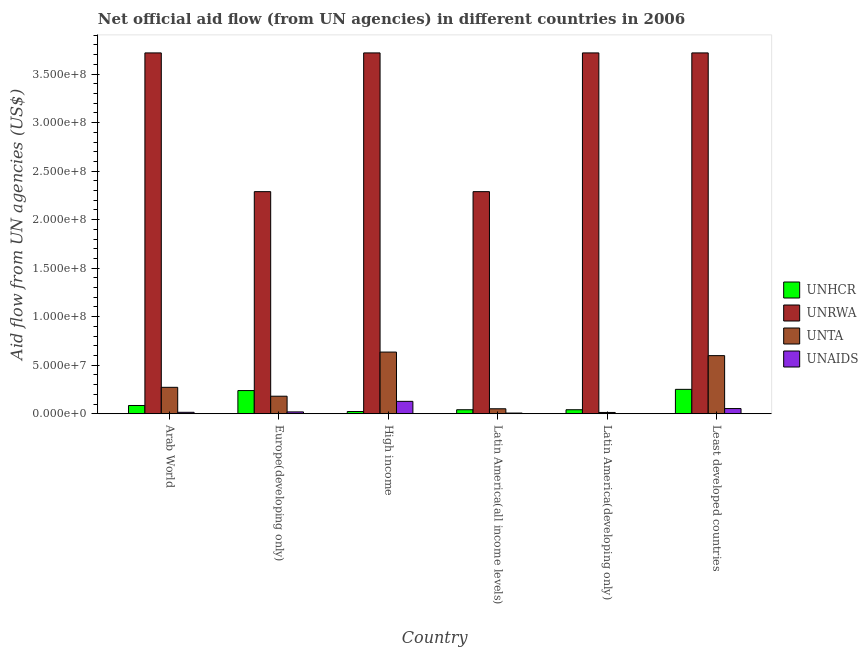How many groups of bars are there?
Offer a terse response. 6. Are the number of bars per tick equal to the number of legend labels?
Ensure brevity in your answer.  Yes. How many bars are there on the 6th tick from the left?
Your response must be concise. 4. How many bars are there on the 1st tick from the right?
Give a very brief answer. 4. What is the label of the 5th group of bars from the left?
Offer a very short reply. Latin America(developing only). In how many cases, is the number of bars for a given country not equal to the number of legend labels?
Offer a very short reply. 0. What is the amount of aid given by unaids in Europe(developing only)?
Your response must be concise. 1.89e+06. Across all countries, what is the maximum amount of aid given by unhcr?
Provide a succinct answer. 2.51e+07. Across all countries, what is the minimum amount of aid given by unta?
Keep it short and to the point. 1.32e+06. In which country was the amount of aid given by unhcr maximum?
Offer a terse response. Least developed countries. In which country was the amount of aid given by unta minimum?
Keep it short and to the point. Latin America(developing only). What is the total amount of aid given by unaids in the graph?
Provide a short and direct response. 2.22e+07. What is the difference between the amount of aid given by unta in High income and that in Least developed countries?
Give a very brief answer. 3.66e+06. What is the difference between the amount of aid given by unta in Latin America(all income levels) and the amount of aid given by unaids in High income?
Your answer should be very brief. -7.65e+06. What is the average amount of aid given by unaids per country?
Your answer should be very brief. 3.70e+06. What is the difference between the amount of aid given by unta and amount of aid given by unhcr in Latin America(developing only)?
Your answer should be compact. -2.79e+06. Is the amount of aid given by unaids in High income less than that in Latin America(all income levels)?
Offer a terse response. No. What is the difference between the highest and the second highest amount of aid given by unaids?
Your answer should be compact. 7.42e+06. What is the difference between the highest and the lowest amount of aid given by unhcr?
Provide a short and direct response. 2.28e+07. In how many countries, is the amount of aid given by unhcr greater than the average amount of aid given by unhcr taken over all countries?
Your answer should be very brief. 2. Is the sum of the amount of aid given by unrwa in High income and Latin America(developing only) greater than the maximum amount of aid given by unaids across all countries?
Provide a succinct answer. Yes. Is it the case that in every country, the sum of the amount of aid given by unta and amount of aid given by unaids is greater than the sum of amount of aid given by unrwa and amount of aid given by unhcr?
Give a very brief answer. No. What does the 1st bar from the left in High income represents?
Make the answer very short. UNHCR. What does the 3rd bar from the right in Europe(developing only) represents?
Make the answer very short. UNRWA. How many bars are there?
Offer a terse response. 24. How many countries are there in the graph?
Give a very brief answer. 6. What is the difference between two consecutive major ticks on the Y-axis?
Make the answer very short. 5.00e+07. Does the graph contain grids?
Your answer should be compact. No. Where does the legend appear in the graph?
Ensure brevity in your answer.  Center right. What is the title of the graph?
Your answer should be very brief. Net official aid flow (from UN agencies) in different countries in 2006. What is the label or title of the Y-axis?
Offer a terse response. Aid flow from UN agencies (US$). What is the Aid flow from UN agencies (US$) in UNHCR in Arab World?
Offer a terse response. 8.50e+06. What is the Aid flow from UN agencies (US$) of UNRWA in Arab World?
Make the answer very short. 3.72e+08. What is the Aid flow from UN agencies (US$) of UNTA in Arab World?
Give a very brief answer. 2.72e+07. What is the Aid flow from UN agencies (US$) in UNAIDS in Arab World?
Provide a succinct answer. 1.48e+06. What is the Aid flow from UN agencies (US$) in UNHCR in Europe(developing only)?
Your answer should be very brief. 2.39e+07. What is the Aid flow from UN agencies (US$) of UNRWA in Europe(developing only)?
Make the answer very short. 2.29e+08. What is the Aid flow from UN agencies (US$) in UNTA in Europe(developing only)?
Make the answer very short. 1.81e+07. What is the Aid flow from UN agencies (US$) of UNAIDS in Europe(developing only)?
Your answer should be compact. 1.89e+06. What is the Aid flow from UN agencies (US$) in UNHCR in High income?
Your answer should be compact. 2.28e+06. What is the Aid flow from UN agencies (US$) of UNRWA in High income?
Provide a short and direct response. 3.72e+08. What is the Aid flow from UN agencies (US$) of UNTA in High income?
Give a very brief answer. 6.35e+07. What is the Aid flow from UN agencies (US$) of UNAIDS in High income?
Make the answer very short. 1.28e+07. What is the Aid flow from UN agencies (US$) of UNHCR in Latin America(all income levels)?
Offer a terse response. 4.11e+06. What is the Aid flow from UN agencies (US$) in UNRWA in Latin America(all income levels)?
Give a very brief answer. 2.29e+08. What is the Aid flow from UN agencies (US$) of UNTA in Latin America(all income levels)?
Ensure brevity in your answer.  5.11e+06. What is the Aid flow from UN agencies (US$) in UNAIDS in Latin America(all income levels)?
Provide a short and direct response. 7.00e+05. What is the Aid flow from UN agencies (US$) of UNHCR in Latin America(developing only)?
Give a very brief answer. 4.11e+06. What is the Aid flow from UN agencies (US$) in UNRWA in Latin America(developing only)?
Ensure brevity in your answer.  3.72e+08. What is the Aid flow from UN agencies (US$) of UNTA in Latin America(developing only)?
Your response must be concise. 1.32e+06. What is the Aid flow from UN agencies (US$) in UNHCR in Least developed countries?
Your response must be concise. 2.51e+07. What is the Aid flow from UN agencies (US$) of UNRWA in Least developed countries?
Your answer should be very brief. 3.72e+08. What is the Aid flow from UN agencies (US$) in UNTA in Least developed countries?
Keep it short and to the point. 5.99e+07. What is the Aid flow from UN agencies (US$) of UNAIDS in Least developed countries?
Your answer should be very brief. 5.34e+06. Across all countries, what is the maximum Aid flow from UN agencies (US$) in UNHCR?
Provide a short and direct response. 2.51e+07. Across all countries, what is the maximum Aid flow from UN agencies (US$) of UNRWA?
Make the answer very short. 3.72e+08. Across all countries, what is the maximum Aid flow from UN agencies (US$) of UNTA?
Your answer should be very brief. 6.35e+07. Across all countries, what is the maximum Aid flow from UN agencies (US$) of UNAIDS?
Provide a succinct answer. 1.28e+07. Across all countries, what is the minimum Aid flow from UN agencies (US$) in UNHCR?
Provide a succinct answer. 2.28e+06. Across all countries, what is the minimum Aid flow from UN agencies (US$) in UNRWA?
Your response must be concise. 2.29e+08. Across all countries, what is the minimum Aid flow from UN agencies (US$) in UNTA?
Your answer should be very brief. 1.32e+06. Across all countries, what is the minimum Aid flow from UN agencies (US$) of UNAIDS?
Your answer should be compact. 3.00e+04. What is the total Aid flow from UN agencies (US$) of UNHCR in the graph?
Your response must be concise. 6.80e+07. What is the total Aid flow from UN agencies (US$) in UNRWA in the graph?
Your answer should be very brief. 1.94e+09. What is the total Aid flow from UN agencies (US$) in UNTA in the graph?
Your response must be concise. 1.75e+08. What is the total Aid flow from UN agencies (US$) in UNAIDS in the graph?
Your response must be concise. 2.22e+07. What is the difference between the Aid flow from UN agencies (US$) of UNHCR in Arab World and that in Europe(developing only)?
Your answer should be compact. -1.54e+07. What is the difference between the Aid flow from UN agencies (US$) in UNRWA in Arab World and that in Europe(developing only)?
Ensure brevity in your answer.  1.43e+08. What is the difference between the Aid flow from UN agencies (US$) in UNTA in Arab World and that in Europe(developing only)?
Your answer should be very brief. 9.16e+06. What is the difference between the Aid flow from UN agencies (US$) of UNAIDS in Arab World and that in Europe(developing only)?
Your answer should be compact. -4.10e+05. What is the difference between the Aid flow from UN agencies (US$) of UNHCR in Arab World and that in High income?
Offer a very short reply. 6.22e+06. What is the difference between the Aid flow from UN agencies (US$) in UNRWA in Arab World and that in High income?
Provide a short and direct response. 0. What is the difference between the Aid flow from UN agencies (US$) in UNTA in Arab World and that in High income?
Keep it short and to the point. -3.63e+07. What is the difference between the Aid flow from UN agencies (US$) in UNAIDS in Arab World and that in High income?
Your answer should be compact. -1.13e+07. What is the difference between the Aid flow from UN agencies (US$) in UNHCR in Arab World and that in Latin America(all income levels)?
Ensure brevity in your answer.  4.39e+06. What is the difference between the Aid flow from UN agencies (US$) of UNRWA in Arab World and that in Latin America(all income levels)?
Your response must be concise. 1.43e+08. What is the difference between the Aid flow from UN agencies (US$) in UNTA in Arab World and that in Latin America(all income levels)?
Keep it short and to the point. 2.21e+07. What is the difference between the Aid flow from UN agencies (US$) of UNAIDS in Arab World and that in Latin America(all income levels)?
Keep it short and to the point. 7.80e+05. What is the difference between the Aid flow from UN agencies (US$) in UNHCR in Arab World and that in Latin America(developing only)?
Your response must be concise. 4.39e+06. What is the difference between the Aid flow from UN agencies (US$) of UNTA in Arab World and that in Latin America(developing only)?
Make the answer very short. 2.59e+07. What is the difference between the Aid flow from UN agencies (US$) in UNAIDS in Arab World and that in Latin America(developing only)?
Ensure brevity in your answer.  1.45e+06. What is the difference between the Aid flow from UN agencies (US$) in UNHCR in Arab World and that in Least developed countries?
Provide a succinct answer. -1.66e+07. What is the difference between the Aid flow from UN agencies (US$) of UNRWA in Arab World and that in Least developed countries?
Give a very brief answer. 0. What is the difference between the Aid flow from UN agencies (US$) of UNTA in Arab World and that in Least developed countries?
Your response must be concise. -3.27e+07. What is the difference between the Aid flow from UN agencies (US$) of UNAIDS in Arab World and that in Least developed countries?
Make the answer very short. -3.86e+06. What is the difference between the Aid flow from UN agencies (US$) in UNHCR in Europe(developing only) and that in High income?
Give a very brief answer. 2.16e+07. What is the difference between the Aid flow from UN agencies (US$) in UNRWA in Europe(developing only) and that in High income?
Give a very brief answer. -1.43e+08. What is the difference between the Aid flow from UN agencies (US$) in UNTA in Europe(developing only) and that in High income?
Ensure brevity in your answer.  -4.55e+07. What is the difference between the Aid flow from UN agencies (US$) of UNAIDS in Europe(developing only) and that in High income?
Provide a succinct answer. -1.09e+07. What is the difference between the Aid flow from UN agencies (US$) in UNHCR in Europe(developing only) and that in Latin America(all income levels)?
Ensure brevity in your answer.  1.98e+07. What is the difference between the Aid flow from UN agencies (US$) in UNTA in Europe(developing only) and that in Latin America(all income levels)?
Your response must be concise. 1.30e+07. What is the difference between the Aid flow from UN agencies (US$) of UNAIDS in Europe(developing only) and that in Latin America(all income levels)?
Ensure brevity in your answer.  1.19e+06. What is the difference between the Aid flow from UN agencies (US$) of UNHCR in Europe(developing only) and that in Latin America(developing only)?
Give a very brief answer. 1.98e+07. What is the difference between the Aid flow from UN agencies (US$) of UNRWA in Europe(developing only) and that in Latin America(developing only)?
Keep it short and to the point. -1.43e+08. What is the difference between the Aid flow from UN agencies (US$) of UNTA in Europe(developing only) and that in Latin America(developing only)?
Offer a very short reply. 1.67e+07. What is the difference between the Aid flow from UN agencies (US$) of UNAIDS in Europe(developing only) and that in Latin America(developing only)?
Provide a short and direct response. 1.86e+06. What is the difference between the Aid flow from UN agencies (US$) of UNHCR in Europe(developing only) and that in Least developed countries?
Make the answer very short. -1.25e+06. What is the difference between the Aid flow from UN agencies (US$) in UNRWA in Europe(developing only) and that in Least developed countries?
Your answer should be compact. -1.43e+08. What is the difference between the Aid flow from UN agencies (US$) of UNTA in Europe(developing only) and that in Least developed countries?
Your answer should be very brief. -4.18e+07. What is the difference between the Aid flow from UN agencies (US$) of UNAIDS in Europe(developing only) and that in Least developed countries?
Your response must be concise. -3.45e+06. What is the difference between the Aid flow from UN agencies (US$) of UNHCR in High income and that in Latin America(all income levels)?
Offer a very short reply. -1.83e+06. What is the difference between the Aid flow from UN agencies (US$) in UNRWA in High income and that in Latin America(all income levels)?
Offer a very short reply. 1.43e+08. What is the difference between the Aid flow from UN agencies (US$) in UNTA in High income and that in Latin America(all income levels)?
Your response must be concise. 5.84e+07. What is the difference between the Aid flow from UN agencies (US$) in UNAIDS in High income and that in Latin America(all income levels)?
Keep it short and to the point. 1.21e+07. What is the difference between the Aid flow from UN agencies (US$) of UNHCR in High income and that in Latin America(developing only)?
Keep it short and to the point. -1.83e+06. What is the difference between the Aid flow from UN agencies (US$) in UNRWA in High income and that in Latin America(developing only)?
Your answer should be compact. 0. What is the difference between the Aid flow from UN agencies (US$) in UNTA in High income and that in Latin America(developing only)?
Your answer should be very brief. 6.22e+07. What is the difference between the Aid flow from UN agencies (US$) of UNAIDS in High income and that in Latin America(developing only)?
Your answer should be very brief. 1.27e+07. What is the difference between the Aid flow from UN agencies (US$) of UNHCR in High income and that in Least developed countries?
Give a very brief answer. -2.28e+07. What is the difference between the Aid flow from UN agencies (US$) of UNRWA in High income and that in Least developed countries?
Keep it short and to the point. 0. What is the difference between the Aid flow from UN agencies (US$) of UNTA in High income and that in Least developed countries?
Offer a terse response. 3.66e+06. What is the difference between the Aid flow from UN agencies (US$) of UNAIDS in High income and that in Least developed countries?
Your response must be concise. 7.42e+06. What is the difference between the Aid flow from UN agencies (US$) in UNRWA in Latin America(all income levels) and that in Latin America(developing only)?
Provide a succinct answer. -1.43e+08. What is the difference between the Aid flow from UN agencies (US$) in UNTA in Latin America(all income levels) and that in Latin America(developing only)?
Your response must be concise. 3.79e+06. What is the difference between the Aid flow from UN agencies (US$) in UNAIDS in Latin America(all income levels) and that in Latin America(developing only)?
Offer a terse response. 6.70e+05. What is the difference between the Aid flow from UN agencies (US$) in UNHCR in Latin America(all income levels) and that in Least developed countries?
Your answer should be compact. -2.10e+07. What is the difference between the Aid flow from UN agencies (US$) in UNRWA in Latin America(all income levels) and that in Least developed countries?
Provide a succinct answer. -1.43e+08. What is the difference between the Aid flow from UN agencies (US$) in UNTA in Latin America(all income levels) and that in Least developed countries?
Provide a succinct answer. -5.48e+07. What is the difference between the Aid flow from UN agencies (US$) in UNAIDS in Latin America(all income levels) and that in Least developed countries?
Give a very brief answer. -4.64e+06. What is the difference between the Aid flow from UN agencies (US$) in UNHCR in Latin America(developing only) and that in Least developed countries?
Your answer should be very brief. -2.10e+07. What is the difference between the Aid flow from UN agencies (US$) in UNTA in Latin America(developing only) and that in Least developed countries?
Your answer should be compact. -5.86e+07. What is the difference between the Aid flow from UN agencies (US$) of UNAIDS in Latin America(developing only) and that in Least developed countries?
Make the answer very short. -5.31e+06. What is the difference between the Aid flow from UN agencies (US$) in UNHCR in Arab World and the Aid flow from UN agencies (US$) in UNRWA in Europe(developing only)?
Ensure brevity in your answer.  -2.20e+08. What is the difference between the Aid flow from UN agencies (US$) in UNHCR in Arab World and the Aid flow from UN agencies (US$) in UNTA in Europe(developing only)?
Offer a terse response. -9.56e+06. What is the difference between the Aid flow from UN agencies (US$) in UNHCR in Arab World and the Aid flow from UN agencies (US$) in UNAIDS in Europe(developing only)?
Your answer should be very brief. 6.61e+06. What is the difference between the Aid flow from UN agencies (US$) of UNRWA in Arab World and the Aid flow from UN agencies (US$) of UNTA in Europe(developing only)?
Offer a very short reply. 3.54e+08. What is the difference between the Aid flow from UN agencies (US$) of UNRWA in Arab World and the Aid flow from UN agencies (US$) of UNAIDS in Europe(developing only)?
Offer a terse response. 3.70e+08. What is the difference between the Aid flow from UN agencies (US$) in UNTA in Arab World and the Aid flow from UN agencies (US$) in UNAIDS in Europe(developing only)?
Make the answer very short. 2.53e+07. What is the difference between the Aid flow from UN agencies (US$) in UNHCR in Arab World and the Aid flow from UN agencies (US$) in UNRWA in High income?
Offer a terse response. -3.63e+08. What is the difference between the Aid flow from UN agencies (US$) of UNHCR in Arab World and the Aid flow from UN agencies (US$) of UNTA in High income?
Provide a succinct answer. -5.50e+07. What is the difference between the Aid flow from UN agencies (US$) of UNHCR in Arab World and the Aid flow from UN agencies (US$) of UNAIDS in High income?
Provide a short and direct response. -4.26e+06. What is the difference between the Aid flow from UN agencies (US$) in UNRWA in Arab World and the Aid flow from UN agencies (US$) in UNTA in High income?
Make the answer very short. 3.08e+08. What is the difference between the Aid flow from UN agencies (US$) of UNRWA in Arab World and the Aid flow from UN agencies (US$) of UNAIDS in High income?
Make the answer very short. 3.59e+08. What is the difference between the Aid flow from UN agencies (US$) of UNTA in Arab World and the Aid flow from UN agencies (US$) of UNAIDS in High income?
Offer a terse response. 1.45e+07. What is the difference between the Aid flow from UN agencies (US$) in UNHCR in Arab World and the Aid flow from UN agencies (US$) in UNRWA in Latin America(all income levels)?
Offer a very short reply. -2.20e+08. What is the difference between the Aid flow from UN agencies (US$) of UNHCR in Arab World and the Aid flow from UN agencies (US$) of UNTA in Latin America(all income levels)?
Offer a very short reply. 3.39e+06. What is the difference between the Aid flow from UN agencies (US$) in UNHCR in Arab World and the Aid flow from UN agencies (US$) in UNAIDS in Latin America(all income levels)?
Your answer should be very brief. 7.80e+06. What is the difference between the Aid flow from UN agencies (US$) of UNRWA in Arab World and the Aid flow from UN agencies (US$) of UNTA in Latin America(all income levels)?
Keep it short and to the point. 3.67e+08. What is the difference between the Aid flow from UN agencies (US$) of UNRWA in Arab World and the Aid flow from UN agencies (US$) of UNAIDS in Latin America(all income levels)?
Offer a very short reply. 3.71e+08. What is the difference between the Aid flow from UN agencies (US$) of UNTA in Arab World and the Aid flow from UN agencies (US$) of UNAIDS in Latin America(all income levels)?
Keep it short and to the point. 2.65e+07. What is the difference between the Aid flow from UN agencies (US$) in UNHCR in Arab World and the Aid flow from UN agencies (US$) in UNRWA in Latin America(developing only)?
Give a very brief answer. -3.63e+08. What is the difference between the Aid flow from UN agencies (US$) in UNHCR in Arab World and the Aid flow from UN agencies (US$) in UNTA in Latin America(developing only)?
Your answer should be very brief. 7.18e+06. What is the difference between the Aid flow from UN agencies (US$) of UNHCR in Arab World and the Aid flow from UN agencies (US$) of UNAIDS in Latin America(developing only)?
Keep it short and to the point. 8.47e+06. What is the difference between the Aid flow from UN agencies (US$) in UNRWA in Arab World and the Aid flow from UN agencies (US$) in UNTA in Latin America(developing only)?
Keep it short and to the point. 3.70e+08. What is the difference between the Aid flow from UN agencies (US$) in UNRWA in Arab World and the Aid flow from UN agencies (US$) in UNAIDS in Latin America(developing only)?
Offer a very short reply. 3.72e+08. What is the difference between the Aid flow from UN agencies (US$) of UNTA in Arab World and the Aid flow from UN agencies (US$) of UNAIDS in Latin America(developing only)?
Your answer should be compact. 2.72e+07. What is the difference between the Aid flow from UN agencies (US$) in UNHCR in Arab World and the Aid flow from UN agencies (US$) in UNRWA in Least developed countries?
Offer a terse response. -3.63e+08. What is the difference between the Aid flow from UN agencies (US$) in UNHCR in Arab World and the Aid flow from UN agencies (US$) in UNTA in Least developed countries?
Offer a very short reply. -5.14e+07. What is the difference between the Aid flow from UN agencies (US$) in UNHCR in Arab World and the Aid flow from UN agencies (US$) in UNAIDS in Least developed countries?
Provide a succinct answer. 3.16e+06. What is the difference between the Aid flow from UN agencies (US$) of UNRWA in Arab World and the Aid flow from UN agencies (US$) of UNTA in Least developed countries?
Make the answer very short. 3.12e+08. What is the difference between the Aid flow from UN agencies (US$) in UNRWA in Arab World and the Aid flow from UN agencies (US$) in UNAIDS in Least developed countries?
Provide a short and direct response. 3.66e+08. What is the difference between the Aid flow from UN agencies (US$) in UNTA in Arab World and the Aid flow from UN agencies (US$) in UNAIDS in Least developed countries?
Offer a terse response. 2.19e+07. What is the difference between the Aid flow from UN agencies (US$) of UNHCR in Europe(developing only) and the Aid flow from UN agencies (US$) of UNRWA in High income?
Provide a short and direct response. -3.48e+08. What is the difference between the Aid flow from UN agencies (US$) in UNHCR in Europe(developing only) and the Aid flow from UN agencies (US$) in UNTA in High income?
Provide a succinct answer. -3.97e+07. What is the difference between the Aid flow from UN agencies (US$) in UNHCR in Europe(developing only) and the Aid flow from UN agencies (US$) in UNAIDS in High income?
Provide a short and direct response. 1.11e+07. What is the difference between the Aid flow from UN agencies (US$) of UNRWA in Europe(developing only) and the Aid flow from UN agencies (US$) of UNTA in High income?
Ensure brevity in your answer.  1.65e+08. What is the difference between the Aid flow from UN agencies (US$) in UNRWA in Europe(developing only) and the Aid flow from UN agencies (US$) in UNAIDS in High income?
Your answer should be very brief. 2.16e+08. What is the difference between the Aid flow from UN agencies (US$) in UNTA in Europe(developing only) and the Aid flow from UN agencies (US$) in UNAIDS in High income?
Make the answer very short. 5.30e+06. What is the difference between the Aid flow from UN agencies (US$) of UNHCR in Europe(developing only) and the Aid flow from UN agencies (US$) of UNRWA in Latin America(all income levels)?
Provide a short and direct response. -2.05e+08. What is the difference between the Aid flow from UN agencies (US$) of UNHCR in Europe(developing only) and the Aid flow from UN agencies (US$) of UNTA in Latin America(all income levels)?
Ensure brevity in your answer.  1.88e+07. What is the difference between the Aid flow from UN agencies (US$) in UNHCR in Europe(developing only) and the Aid flow from UN agencies (US$) in UNAIDS in Latin America(all income levels)?
Make the answer very short. 2.32e+07. What is the difference between the Aid flow from UN agencies (US$) in UNRWA in Europe(developing only) and the Aid flow from UN agencies (US$) in UNTA in Latin America(all income levels)?
Offer a terse response. 2.24e+08. What is the difference between the Aid flow from UN agencies (US$) in UNRWA in Europe(developing only) and the Aid flow from UN agencies (US$) in UNAIDS in Latin America(all income levels)?
Ensure brevity in your answer.  2.28e+08. What is the difference between the Aid flow from UN agencies (US$) of UNTA in Europe(developing only) and the Aid flow from UN agencies (US$) of UNAIDS in Latin America(all income levels)?
Your response must be concise. 1.74e+07. What is the difference between the Aid flow from UN agencies (US$) of UNHCR in Europe(developing only) and the Aid flow from UN agencies (US$) of UNRWA in Latin America(developing only)?
Provide a short and direct response. -3.48e+08. What is the difference between the Aid flow from UN agencies (US$) in UNHCR in Europe(developing only) and the Aid flow from UN agencies (US$) in UNTA in Latin America(developing only)?
Provide a short and direct response. 2.26e+07. What is the difference between the Aid flow from UN agencies (US$) in UNHCR in Europe(developing only) and the Aid flow from UN agencies (US$) in UNAIDS in Latin America(developing only)?
Your answer should be very brief. 2.38e+07. What is the difference between the Aid flow from UN agencies (US$) of UNRWA in Europe(developing only) and the Aid flow from UN agencies (US$) of UNTA in Latin America(developing only)?
Your response must be concise. 2.28e+08. What is the difference between the Aid flow from UN agencies (US$) of UNRWA in Europe(developing only) and the Aid flow from UN agencies (US$) of UNAIDS in Latin America(developing only)?
Your answer should be compact. 2.29e+08. What is the difference between the Aid flow from UN agencies (US$) of UNTA in Europe(developing only) and the Aid flow from UN agencies (US$) of UNAIDS in Latin America(developing only)?
Make the answer very short. 1.80e+07. What is the difference between the Aid flow from UN agencies (US$) of UNHCR in Europe(developing only) and the Aid flow from UN agencies (US$) of UNRWA in Least developed countries?
Provide a succinct answer. -3.48e+08. What is the difference between the Aid flow from UN agencies (US$) of UNHCR in Europe(developing only) and the Aid flow from UN agencies (US$) of UNTA in Least developed countries?
Make the answer very short. -3.60e+07. What is the difference between the Aid flow from UN agencies (US$) in UNHCR in Europe(developing only) and the Aid flow from UN agencies (US$) in UNAIDS in Least developed countries?
Provide a succinct answer. 1.85e+07. What is the difference between the Aid flow from UN agencies (US$) in UNRWA in Europe(developing only) and the Aid flow from UN agencies (US$) in UNTA in Least developed countries?
Provide a short and direct response. 1.69e+08. What is the difference between the Aid flow from UN agencies (US$) in UNRWA in Europe(developing only) and the Aid flow from UN agencies (US$) in UNAIDS in Least developed countries?
Offer a very short reply. 2.24e+08. What is the difference between the Aid flow from UN agencies (US$) in UNTA in Europe(developing only) and the Aid flow from UN agencies (US$) in UNAIDS in Least developed countries?
Offer a very short reply. 1.27e+07. What is the difference between the Aid flow from UN agencies (US$) of UNHCR in High income and the Aid flow from UN agencies (US$) of UNRWA in Latin America(all income levels)?
Your answer should be compact. -2.27e+08. What is the difference between the Aid flow from UN agencies (US$) in UNHCR in High income and the Aid flow from UN agencies (US$) in UNTA in Latin America(all income levels)?
Your response must be concise. -2.83e+06. What is the difference between the Aid flow from UN agencies (US$) in UNHCR in High income and the Aid flow from UN agencies (US$) in UNAIDS in Latin America(all income levels)?
Give a very brief answer. 1.58e+06. What is the difference between the Aid flow from UN agencies (US$) of UNRWA in High income and the Aid flow from UN agencies (US$) of UNTA in Latin America(all income levels)?
Your answer should be very brief. 3.67e+08. What is the difference between the Aid flow from UN agencies (US$) in UNRWA in High income and the Aid flow from UN agencies (US$) in UNAIDS in Latin America(all income levels)?
Give a very brief answer. 3.71e+08. What is the difference between the Aid flow from UN agencies (US$) in UNTA in High income and the Aid flow from UN agencies (US$) in UNAIDS in Latin America(all income levels)?
Offer a terse response. 6.28e+07. What is the difference between the Aid flow from UN agencies (US$) in UNHCR in High income and the Aid flow from UN agencies (US$) in UNRWA in Latin America(developing only)?
Keep it short and to the point. -3.70e+08. What is the difference between the Aid flow from UN agencies (US$) in UNHCR in High income and the Aid flow from UN agencies (US$) in UNTA in Latin America(developing only)?
Keep it short and to the point. 9.60e+05. What is the difference between the Aid flow from UN agencies (US$) in UNHCR in High income and the Aid flow from UN agencies (US$) in UNAIDS in Latin America(developing only)?
Provide a short and direct response. 2.25e+06. What is the difference between the Aid flow from UN agencies (US$) in UNRWA in High income and the Aid flow from UN agencies (US$) in UNTA in Latin America(developing only)?
Your answer should be very brief. 3.70e+08. What is the difference between the Aid flow from UN agencies (US$) in UNRWA in High income and the Aid flow from UN agencies (US$) in UNAIDS in Latin America(developing only)?
Your response must be concise. 3.72e+08. What is the difference between the Aid flow from UN agencies (US$) in UNTA in High income and the Aid flow from UN agencies (US$) in UNAIDS in Latin America(developing only)?
Provide a short and direct response. 6.35e+07. What is the difference between the Aid flow from UN agencies (US$) of UNHCR in High income and the Aid flow from UN agencies (US$) of UNRWA in Least developed countries?
Offer a very short reply. -3.70e+08. What is the difference between the Aid flow from UN agencies (US$) of UNHCR in High income and the Aid flow from UN agencies (US$) of UNTA in Least developed countries?
Keep it short and to the point. -5.76e+07. What is the difference between the Aid flow from UN agencies (US$) in UNHCR in High income and the Aid flow from UN agencies (US$) in UNAIDS in Least developed countries?
Your answer should be very brief. -3.06e+06. What is the difference between the Aid flow from UN agencies (US$) in UNRWA in High income and the Aid flow from UN agencies (US$) in UNTA in Least developed countries?
Provide a short and direct response. 3.12e+08. What is the difference between the Aid flow from UN agencies (US$) of UNRWA in High income and the Aid flow from UN agencies (US$) of UNAIDS in Least developed countries?
Keep it short and to the point. 3.66e+08. What is the difference between the Aid flow from UN agencies (US$) in UNTA in High income and the Aid flow from UN agencies (US$) in UNAIDS in Least developed countries?
Keep it short and to the point. 5.82e+07. What is the difference between the Aid flow from UN agencies (US$) of UNHCR in Latin America(all income levels) and the Aid flow from UN agencies (US$) of UNRWA in Latin America(developing only)?
Keep it short and to the point. -3.68e+08. What is the difference between the Aid flow from UN agencies (US$) in UNHCR in Latin America(all income levels) and the Aid flow from UN agencies (US$) in UNTA in Latin America(developing only)?
Provide a succinct answer. 2.79e+06. What is the difference between the Aid flow from UN agencies (US$) of UNHCR in Latin America(all income levels) and the Aid flow from UN agencies (US$) of UNAIDS in Latin America(developing only)?
Your response must be concise. 4.08e+06. What is the difference between the Aid flow from UN agencies (US$) in UNRWA in Latin America(all income levels) and the Aid flow from UN agencies (US$) in UNTA in Latin America(developing only)?
Ensure brevity in your answer.  2.28e+08. What is the difference between the Aid flow from UN agencies (US$) in UNRWA in Latin America(all income levels) and the Aid flow from UN agencies (US$) in UNAIDS in Latin America(developing only)?
Ensure brevity in your answer.  2.29e+08. What is the difference between the Aid flow from UN agencies (US$) in UNTA in Latin America(all income levels) and the Aid flow from UN agencies (US$) in UNAIDS in Latin America(developing only)?
Give a very brief answer. 5.08e+06. What is the difference between the Aid flow from UN agencies (US$) of UNHCR in Latin America(all income levels) and the Aid flow from UN agencies (US$) of UNRWA in Least developed countries?
Your response must be concise. -3.68e+08. What is the difference between the Aid flow from UN agencies (US$) in UNHCR in Latin America(all income levels) and the Aid flow from UN agencies (US$) in UNTA in Least developed countries?
Make the answer very short. -5.58e+07. What is the difference between the Aid flow from UN agencies (US$) in UNHCR in Latin America(all income levels) and the Aid flow from UN agencies (US$) in UNAIDS in Least developed countries?
Offer a very short reply. -1.23e+06. What is the difference between the Aid flow from UN agencies (US$) in UNRWA in Latin America(all income levels) and the Aid flow from UN agencies (US$) in UNTA in Least developed countries?
Your response must be concise. 1.69e+08. What is the difference between the Aid flow from UN agencies (US$) in UNRWA in Latin America(all income levels) and the Aid flow from UN agencies (US$) in UNAIDS in Least developed countries?
Keep it short and to the point. 2.24e+08. What is the difference between the Aid flow from UN agencies (US$) of UNHCR in Latin America(developing only) and the Aid flow from UN agencies (US$) of UNRWA in Least developed countries?
Your answer should be very brief. -3.68e+08. What is the difference between the Aid flow from UN agencies (US$) in UNHCR in Latin America(developing only) and the Aid flow from UN agencies (US$) in UNTA in Least developed countries?
Offer a terse response. -5.58e+07. What is the difference between the Aid flow from UN agencies (US$) of UNHCR in Latin America(developing only) and the Aid flow from UN agencies (US$) of UNAIDS in Least developed countries?
Keep it short and to the point. -1.23e+06. What is the difference between the Aid flow from UN agencies (US$) of UNRWA in Latin America(developing only) and the Aid flow from UN agencies (US$) of UNTA in Least developed countries?
Offer a terse response. 3.12e+08. What is the difference between the Aid flow from UN agencies (US$) in UNRWA in Latin America(developing only) and the Aid flow from UN agencies (US$) in UNAIDS in Least developed countries?
Make the answer very short. 3.66e+08. What is the difference between the Aid flow from UN agencies (US$) in UNTA in Latin America(developing only) and the Aid flow from UN agencies (US$) in UNAIDS in Least developed countries?
Offer a very short reply. -4.02e+06. What is the average Aid flow from UN agencies (US$) of UNHCR per country?
Provide a succinct answer. 1.13e+07. What is the average Aid flow from UN agencies (US$) in UNRWA per country?
Your answer should be compact. 3.24e+08. What is the average Aid flow from UN agencies (US$) of UNTA per country?
Offer a terse response. 2.92e+07. What is the average Aid flow from UN agencies (US$) in UNAIDS per country?
Offer a terse response. 3.70e+06. What is the difference between the Aid flow from UN agencies (US$) in UNHCR and Aid flow from UN agencies (US$) in UNRWA in Arab World?
Ensure brevity in your answer.  -3.63e+08. What is the difference between the Aid flow from UN agencies (US$) of UNHCR and Aid flow from UN agencies (US$) of UNTA in Arab World?
Your answer should be compact. -1.87e+07. What is the difference between the Aid flow from UN agencies (US$) of UNHCR and Aid flow from UN agencies (US$) of UNAIDS in Arab World?
Your answer should be compact. 7.02e+06. What is the difference between the Aid flow from UN agencies (US$) of UNRWA and Aid flow from UN agencies (US$) of UNTA in Arab World?
Make the answer very short. 3.45e+08. What is the difference between the Aid flow from UN agencies (US$) in UNRWA and Aid flow from UN agencies (US$) in UNAIDS in Arab World?
Your answer should be very brief. 3.70e+08. What is the difference between the Aid flow from UN agencies (US$) of UNTA and Aid flow from UN agencies (US$) of UNAIDS in Arab World?
Offer a very short reply. 2.57e+07. What is the difference between the Aid flow from UN agencies (US$) in UNHCR and Aid flow from UN agencies (US$) in UNRWA in Europe(developing only)?
Keep it short and to the point. -2.05e+08. What is the difference between the Aid flow from UN agencies (US$) of UNHCR and Aid flow from UN agencies (US$) of UNTA in Europe(developing only)?
Give a very brief answer. 5.82e+06. What is the difference between the Aid flow from UN agencies (US$) in UNHCR and Aid flow from UN agencies (US$) in UNAIDS in Europe(developing only)?
Make the answer very short. 2.20e+07. What is the difference between the Aid flow from UN agencies (US$) of UNRWA and Aid flow from UN agencies (US$) of UNTA in Europe(developing only)?
Ensure brevity in your answer.  2.11e+08. What is the difference between the Aid flow from UN agencies (US$) of UNRWA and Aid flow from UN agencies (US$) of UNAIDS in Europe(developing only)?
Keep it short and to the point. 2.27e+08. What is the difference between the Aid flow from UN agencies (US$) of UNTA and Aid flow from UN agencies (US$) of UNAIDS in Europe(developing only)?
Your response must be concise. 1.62e+07. What is the difference between the Aid flow from UN agencies (US$) of UNHCR and Aid flow from UN agencies (US$) of UNRWA in High income?
Provide a succinct answer. -3.70e+08. What is the difference between the Aid flow from UN agencies (US$) in UNHCR and Aid flow from UN agencies (US$) in UNTA in High income?
Ensure brevity in your answer.  -6.13e+07. What is the difference between the Aid flow from UN agencies (US$) of UNHCR and Aid flow from UN agencies (US$) of UNAIDS in High income?
Offer a terse response. -1.05e+07. What is the difference between the Aid flow from UN agencies (US$) in UNRWA and Aid flow from UN agencies (US$) in UNTA in High income?
Your response must be concise. 3.08e+08. What is the difference between the Aid flow from UN agencies (US$) of UNRWA and Aid flow from UN agencies (US$) of UNAIDS in High income?
Ensure brevity in your answer.  3.59e+08. What is the difference between the Aid flow from UN agencies (US$) of UNTA and Aid flow from UN agencies (US$) of UNAIDS in High income?
Give a very brief answer. 5.08e+07. What is the difference between the Aid flow from UN agencies (US$) in UNHCR and Aid flow from UN agencies (US$) in UNRWA in Latin America(all income levels)?
Offer a terse response. -2.25e+08. What is the difference between the Aid flow from UN agencies (US$) in UNHCR and Aid flow from UN agencies (US$) in UNAIDS in Latin America(all income levels)?
Ensure brevity in your answer.  3.41e+06. What is the difference between the Aid flow from UN agencies (US$) of UNRWA and Aid flow from UN agencies (US$) of UNTA in Latin America(all income levels)?
Give a very brief answer. 2.24e+08. What is the difference between the Aid flow from UN agencies (US$) in UNRWA and Aid flow from UN agencies (US$) in UNAIDS in Latin America(all income levels)?
Give a very brief answer. 2.28e+08. What is the difference between the Aid flow from UN agencies (US$) in UNTA and Aid flow from UN agencies (US$) in UNAIDS in Latin America(all income levels)?
Provide a short and direct response. 4.41e+06. What is the difference between the Aid flow from UN agencies (US$) in UNHCR and Aid flow from UN agencies (US$) in UNRWA in Latin America(developing only)?
Offer a very short reply. -3.68e+08. What is the difference between the Aid flow from UN agencies (US$) in UNHCR and Aid flow from UN agencies (US$) in UNTA in Latin America(developing only)?
Offer a very short reply. 2.79e+06. What is the difference between the Aid flow from UN agencies (US$) in UNHCR and Aid flow from UN agencies (US$) in UNAIDS in Latin America(developing only)?
Offer a very short reply. 4.08e+06. What is the difference between the Aid flow from UN agencies (US$) of UNRWA and Aid flow from UN agencies (US$) of UNTA in Latin America(developing only)?
Give a very brief answer. 3.70e+08. What is the difference between the Aid flow from UN agencies (US$) in UNRWA and Aid flow from UN agencies (US$) in UNAIDS in Latin America(developing only)?
Keep it short and to the point. 3.72e+08. What is the difference between the Aid flow from UN agencies (US$) in UNTA and Aid flow from UN agencies (US$) in UNAIDS in Latin America(developing only)?
Your answer should be compact. 1.29e+06. What is the difference between the Aid flow from UN agencies (US$) of UNHCR and Aid flow from UN agencies (US$) of UNRWA in Least developed countries?
Your response must be concise. -3.47e+08. What is the difference between the Aid flow from UN agencies (US$) in UNHCR and Aid flow from UN agencies (US$) in UNTA in Least developed countries?
Give a very brief answer. -3.48e+07. What is the difference between the Aid flow from UN agencies (US$) of UNHCR and Aid flow from UN agencies (US$) of UNAIDS in Least developed countries?
Provide a short and direct response. 1.98e+07. What is the difference between the Aid flow from UN agencies (US$) of UNRWA and Aid flow from UN agencies (US$) of UNTA in Least developed countries?
Provide a short and direct response. 3.12e+08. What is the difference between the Aid flow from UN agencies (US$) in UNRWA and Aid flow from UN agencies (US$) in UNAIDS in Least developed countries?
Offer a very short reply. 3.66e+08. What is the difference between the Aid flow from UN agencies (US$) in UNTA and Aid flow from UN agencies (US$) in UNAIDS in Least developed countries?
Offer a very short reply. 5.45e+07. What is the ratio of the Aid flow from UN agencies (US$) of UNHCR in Arab World to that in Europe(developing only)?
Make the answer very short. 0.36. What is the ratio of the Aid flow from UN agencies (US$) of UNRWA in Arab World to that in Europe(developing only)?
Provide a short and direct response. 1.62. What is the ratio of the Aid flow from UN agencies (US$) in UNTA in Arab World to that in Europe(developing only)?
Make the answer very short. 1.51. What is the ratio of the Aid flow from UN agencies (US$) in UNAIDS in Arab World to that in Europe(developing only)?
Your answer should be very brief. 0.78. What is the ratio of the Aid flow from UN agencies (US$) in UNHCR in Arab World to that in High income?
Provide a short and direct response. 3.73. What is the ratio of the Aid flow from UN agencies (US$) of UNTA in Arab World to that in High income?
Offer a terse response. 0.43. What is the ratio of the Aid flow from UN agencies (US$) of UNAIDS in Arab World to that in High income?
Your response must be concise. 0.12. What is the ratio of the Aid flow from UN agencies (US$) of UNHCR in Arab World to that in Latin America(all income levels)?
Ensure brevity in your answer.  2.07. What is the ratio of the Aid flow from UN agencies (US$) of UNRWA in Arab World to that in Latin America(all income levels)?
Offer a terse response. 1.62. What is the ratio of the Aid flow from UN agencies (US$) in UNTA in Arab World to that in Latin America(all income levels)?
Ensure brevity in your answer.  5.33. What is the ratio of the Aid flow from UN agencies (US$) of UNAIDS in Arab World to that in Latin America(all income levels)?
Provide a short and direct response. 2.11. What is the ratio of the Aid flow from UN agencies (US$) in UNHCR in Arab World to that in Latin America(developing only)?
Make the answer very short. 2.07. What is the ratio of the Aid flow from UN agencies (US$) of UNTA in Arab World to that in Latin America(developing only)?
Keep it short and to the point. 20.62. What is the ratio of the Aid flow from UN agencies (US$) in UNAIDS in Arab World to that in Latin America(developing only)?
Offer a very short reply. 49.33. What is the ratio of the Aid flow from UN agencies (US$) of UNHCR in Arab World to that in Least developed countries?
Give a very brief answer. 0.34. What is the ratio of the Aid flow from UN agencies (US$) of UNTA in Arab World to that in Least developed countries?
Your response must be concise. 0.45. What is the ratio of the Aid flow from UN agencies (US$) of UNAIDS in Arab World to that in Least developed countries?
Keep it short and to the point. 0.28. What is the ratio of the Aid flow from UN agencies (US$) in UNHCR in Europe(developing only) to that in High income?
Ensure brevity in your answer.  10.47. What is the ratio of the Aid flow from UN agencies (US$) of UNRWA in Europe(developing only) to that in High income?
Your answer should be very brief. 0.62. What is the ratio of the Aid flow from UN agencies (US$) of UNTA in Europe(developing only) to that in High income?
Provide a short and direct response. 0.28. What is the ratio of the Aid flow from UN agencies (US$) of UNAIDS in Europe(developing only) to that in High income?
Your answer should be compact. 0.15. What is the ratio of the Aid flow from UN agencies (US$) of UNHCR in Europe(developing only) to that in Latin America(all income levels)?
Your answer should be very brief. 5.81. What is the ratio of the Aid flow from UN agencies (US$) of UNTA in Europe(developing only) to that in Latin America(all income levels)?
Make the answer very short. 3.53. What is the ratio of the Aid flow from UN agencies (US$) of UNHCR in Europe(developing only) to that in Latin America(developing only)?
Your answer should be very brief. 5.81. What is the ratio of the Aid flow from UN agencies (US$) in UNRWA in Europe(developing only) to that in Latin America(developing only)?
Your answer should be very brief. 0.62. What is the ratio of the Aid flow from UN agencies (US$) in UNTA in Europe(developing only) to that in Latin America(developing only)?
Offer a very short reply. 13.68. What is the ratio of the Aid flow from UN agencies (US$) in UNAIDS in Europe(developing only) to that in Latin America(developing only)?
Make the answer very short. 63. What is the ratio of the Aid flow from UN agencies (US$) in UNHCR in Europe(developing only) to that in Least developed countries?
Offer a very short reply. 0.95. What is the ratio of the Aid flow from UN agencies (US$) in UNRWA in Europe(developing only) to that in Least developed countries?
Provide a short and direct response. 0.62. What is the ratio of the Aid flow from UN agencies (US$) of UNTA in Europe(developing only) to that in Least developed countries?
Provide a succinct answer. 0.3. What is the ratio of the Aid flow from UN agencies (US$) of UNAIDS in Europe(developing only) to that in Least developed countries?
Provide a short and direct response. 0.35. What is the ratio of the Aid flow from UN agencies (US$) in UNHCR in High income to that in Latin America(all income levels)?
Ensure brevity in your answer.  0.55. What is the ratio of the Aid flow from UN agencies (US$) in UNRWA in High income to that in Latin America(all income levels)?
Your answer should be very brief. 1.62. What is the ratio of the Aid flow from UN agencies (US$) in UNTA in High income to that in Latin America(all income levels)?
Offer a very short reply. 12.43. What is the ratio of the Aid flow from UN agencies (US$) in UNAIDS in High income to that in Latin America(all income levels)?
Provide a succinct answer. 18.23. What is the ratio of the Aid flow from UN agencies (US$) in UNHCR in High income to that in Latin America(developing only)?
Your response must be concise. 0.55. What is the ratio of the Aid flow from UN agencies (US$) in UNRWA in High income to that in Latin America(developing only)?
Offer a terse response. 1. What is the ratio of the Aid flow from UN agencies (US$) in UNTA in High income to that in Latin America(developing only)?
Make the answer very short. 48.14. What is the ratio of the Aid flow from UN agencies (US$) in UNAIDS in High income to that in Latin America(developing only)?
Keep it short and to the point. 425.33. What is the ratio of the Aid flow from UN agencies (US$) in UNHCR in High income to that in Least developed countries?
Offer a very short reply. 0.09. What is the ratio of the Aid flow from UN agencies (US$) in UNRWA in High income to that in Least developed countries?
Your response must be concise. 1. What is the ratio of the Aid flow from UN agencies (US$) of UNTA in High income to that in Least developed countries?
Give a very brief answer. 1.06. What is the ratio of the Aid flow from UN agencies (US$) in UNAIDS in High income to that in Least developed countries?
Offer a very short reply. 2.39. What is the ratio of the Aid flow from UN agencies (US$) in UNRWA in Latin America(all income levels) to that in Latin America(developing only)?
Offer a terse response. 0.62. What is the ratio of the Aid flow from UN agencies (US$) of UNTA in Latin America(all income levels) to that in Latin America(developing only)?
Ensure brevity in your answer.  3.87. What is the ratio of the Aid flow from UN agencies (US$) of UNAIDS in Latin America(all income levels) to that in Latin America(developing only)?
Offer a terse response. 23.33. What is the ratio of the Aid flow from UN agencies (US$) of UNHCR in Latin America(all income levels) to that in Least developed countries?
Offer a terse response. 0.16. What is the ratio of the Aid flow from UN agencies (US$) of UNRWA in Latin America(all income levels) to that in Least developed countries?
Ensure brevity in your answer.  0.62. What is the ratio of the Aid flow from UN agencies (US$) in UNTA in Latin America(all income levels) to that in Least developed countries?
Provide a short and direct response. 0.09. What is the ratio of the Aid flow from UN agencies (US$) in UNAIDS in Latin America(all income levels) to that in Least developed countries?
Your answer should be compact. 0.13. What is the ratio of the Aid flow from UN agencies (US$) of UNHCR in Latin America(developing only) to that in Least developed countries?
Give a very brief answer. 0.16. What is the ratio of the Aid flow from UN agencies (US$) in UNRWA in Latin America(developing only) to that in Least developed countries?
Your response must be concise. 1. What is the ratio of the Aid flow from UN agencies (US$) in UNTA in Latin America(developing only) to that in Least developed countries?
Offer a very short reply. 0.02. What is the ratio of the Aid flow from UN agencies (US$) in UNAIDS in Latin America(developing only) to that in Least developed countries?
Provide a succinct answer. 0.01. What is the difference between the highest and the second highest Aid flow from UN agencies (US$) in UNHCR?
Make the answer very short. 1.25e+06. What is the difference between the highest and the second highest Aid flow from UN agencies (US$) in UNRWA?
Provide a short and direct response. 0. What is the difference between the highest and the second highest Aid flow from UN agencies (US$) in UNTA?
Keep it short and to the point. 3.66e+06. What is the difference between the highest and the second highest Aid flow from UN agencies (US$) in UNAIDS?
Your response must be concise. 7.42e+06. What is the difference between the highest and the lowest Aid flow from UN agencies (US$) of UNHCR?
Make the answer very short. 2.28e+07. What is the difference between the highest and the lowest Aid flow from UN agencies (US$) of UNRWA?
Provide a short and direct response. 1.43e+08. What is the difference between the highest and the lowest Aid flow from UN agencies (US$) in UNTA?
Ensure brevity in your answer.  6.22e+07. What is the difference between the highest and the lowest Aid flow from UN agencies (US$) in UNAIDS?
Make the answer very short. 1.27e+07. 